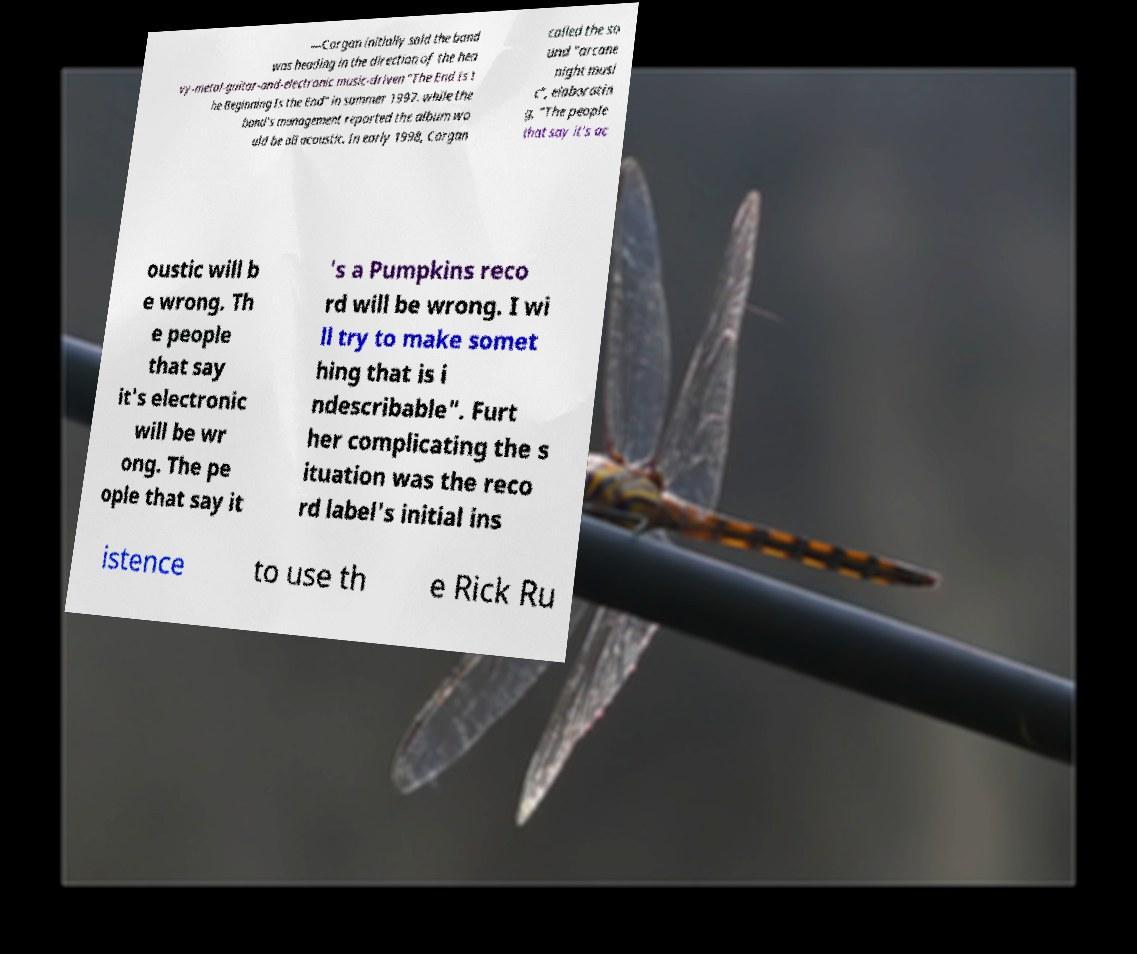Could you assist in decoding the text presented in this image and type it out clearly? —Corgan initially said the band was heading in the direction of the hea vy-metal-guitar-and-electronic music-driven "The End Is t he Beginning Is the End" in summer 1997. while the band's management reported the album wo uld be all acoustic. In early 1998, Corgan called the so und "arcane night musi c", elaboratin g, "The people that say it's ac oustic will b e wrong. Th e people that say it's electronic will be wr ong. The pe ople that say it 's a Pumpkins reco rd will be wrong. I wi ll try to make somet hing that is i ndescribable". Furt her complicating the s ituation was the reco rd label's initial ins istence to use th e Rick Ru 